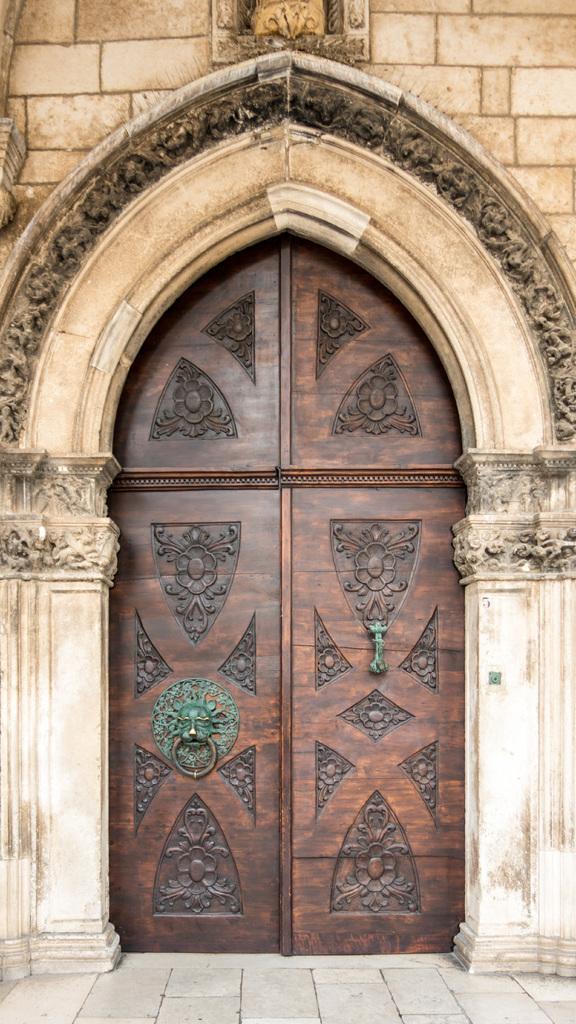How would you summarize this image in a sentence or two? In the image there is a door below the wall and around the door there is an arch it is having some carvings, the door is closed. 